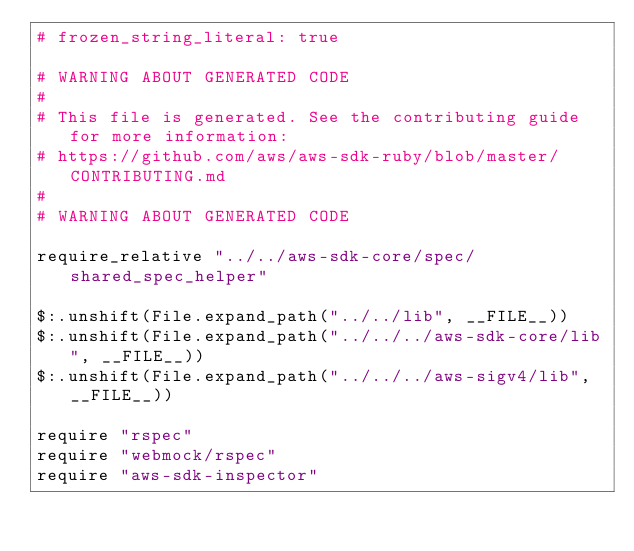Convert code to text. <code><loc_0><loc_0><loc_500><loc_500><_Crystal_># frozen_string_literal: true

# WARNING ABOUT GENERATED CODE
#
# This file is generated. See the contributing guide for more information:
# https://github.com/aws/aws-sdk-ruby/blob/master/CONTRIBUTING.md
#
# WARNING ABOUT GENERATED CODE

require_relative "../../aws-sdk-core/spec/shared_spec_helper"

$:.unshift(File.expand_path("../../lib", __FILE__))
$:.unshift(File.expand_path("../../../aws-sdk-core/lib", __FILE__))
$:.unshift(File.expand_path("../../../aws-sigv4/lib", __FILE__))

require "rspec"
require "webmock/rspec"
require "aws-sdk-inspector"
</code> 